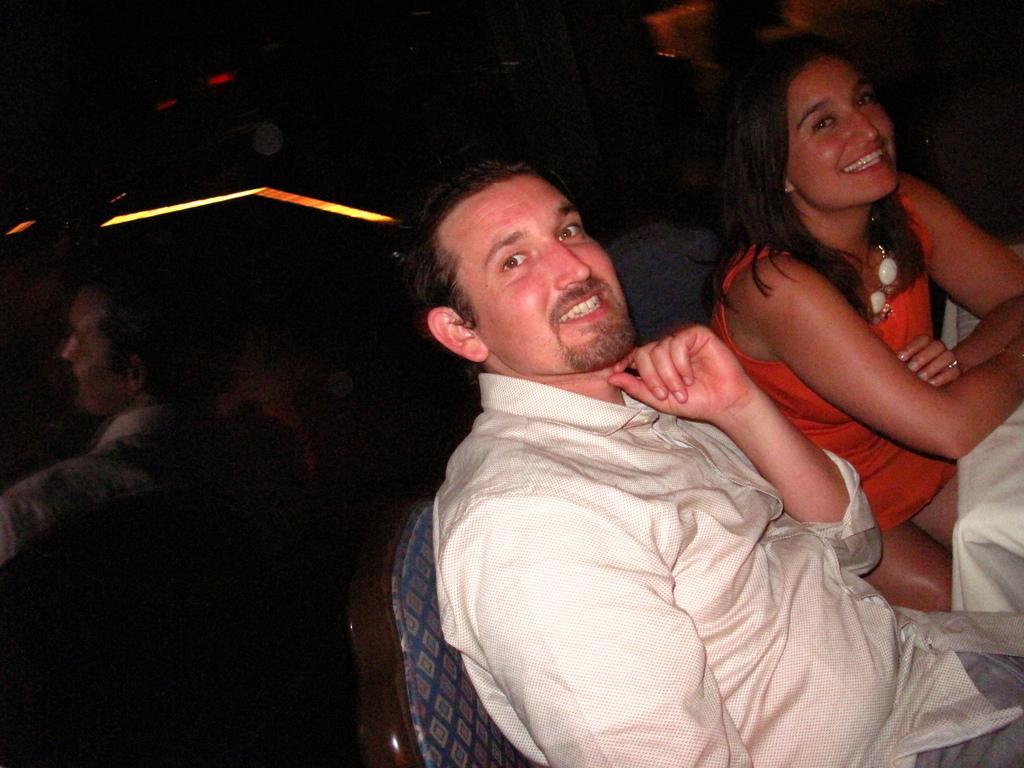Describe this image in one or two sentences. Here in this picture we can see man and a woman sitting on chairs with a table in front of them and we can see both of them are smiling and behind them we can see a glass, on which we can see reflection of them. 